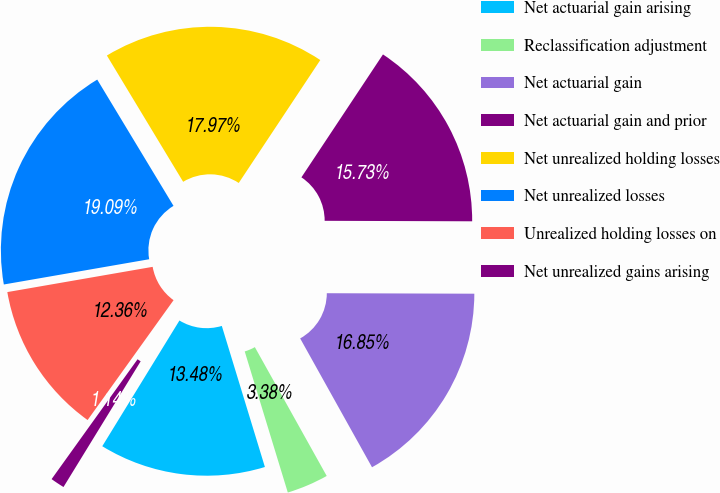Convert chart to OTSL. <chart><loc_0><loc_0><loc_500><loc_500><pie_chart><fcel>Net actuarial gain arising<fcel>Reclassification adjustment<fcel>Net actuarial gain<fcel>Net actuarial gain and prior<fcel>Net unrealized holding losses<fcel>Net unrealized losses<fcel>Unrealized holding losses on<fcel>Net unrealized gains arising<nl><fcel>13.48%<fcel>3.38%<fcel>16.85%<fcel>15.73%<fcel>17.97%<fcel>19.09%<fcel>12.36%<fcel>1.14%<nl></chart> 